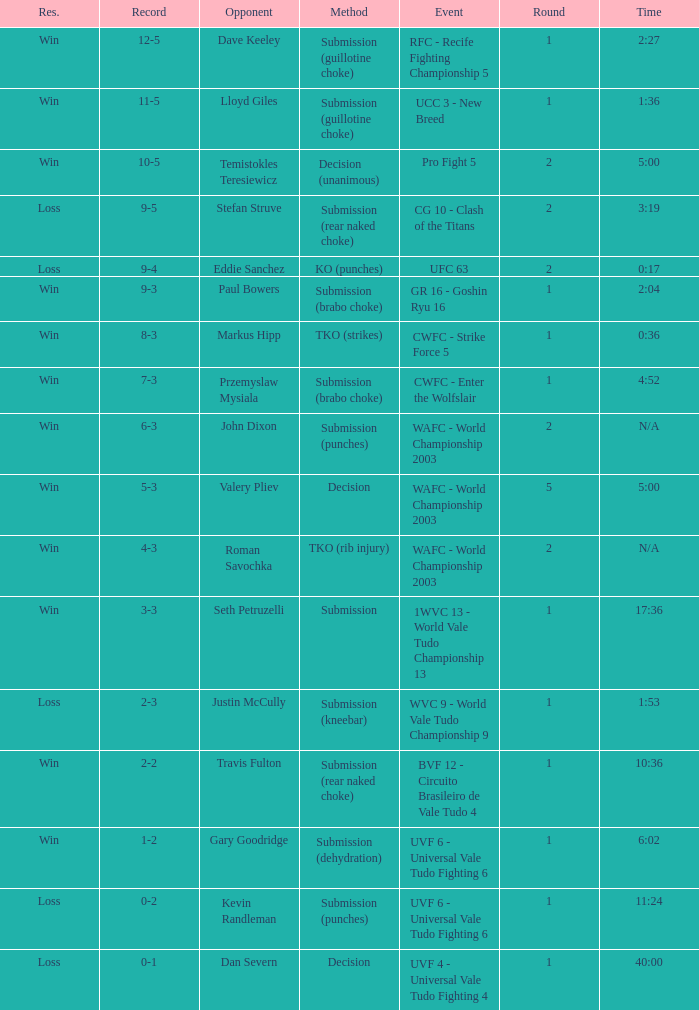Would you mind parsing the complete table? {'header': ['Res.', 'Record', 'Opponent', 'Method', 'Event', 'Round', 'Time'], 'rows': [['Win', '12-5', 'Dave Keeley', 'Submission (guillotine choke)', 'RFC - Recife Fighting Championship 5', '1', '2:27'], ['Win', '11-5', 'Lloyd Giles', 'Submission (guillotine choke)', 'UCC 3 - New Breed', '1', '1:36'], ['Win', '10-5', 'Temistokles Teresiewicz', 'Decision (unanimous)', 'Pro Fight 5', '2', '5:00'], ['Loss', '9-5', 'Stefan Struve', 'Submission (rear naked choke)', 'CG 10 - Clash of the Titans', '2', '3:19'], ['Loss', '9-4', 'Eddie Sanchez', 'KO (punches)', 'UFC 63', '2', '0:17'], ['Win', '9-3', 'Paul Bowers', 'Submission (brabo choke)', 'GR 16 - Goshin Ryu 16', '1', '2:04'], ['Win', '8-3', 'Markus Hipp', 'TKO (strikes)', 'CWFC - Strike Force 5', '1', '0:36'], ['Win', '7-3', 'Przemyslaw Mysiala', 'Submission (brabo choke)', 'CWFC - Enter the Wolfslair', '1', '4:52'], ['Win', '6-3', 'John Dixon', 'Submission (punches)', 'WAFC - World Championship 2003', '2', 'N/A'], ['Win', '5-3', 'Valery Pliev', 'Decision', 'WAFC - World Championship 2003', '5', '5:00'], ['Win', '4-3', 'Roman Savochka', 'TKO (rib injury)', 'WAFC - World Championship 2003', '2', 'N/A'], ['Win', '3-3', 'Seth Petruzelli', 'Submission', '1WVC 13 - World Vale Tudo Championship 13', '1', '17:36'], ['Loss', '2-3', 'Justin McCully', 'Submission (kneebar)', 'WVC 9 - World Vale Tudo Championship 9', '1', '1:53'], ['Win', '2-2', 'Travis Fulton', 'Submission (rear naked choke)', 'BVF 12 - Circuito Brasileiro de Vale Tudo 4', '1', '10:36'], ['Win', '1-2', 'Gary Goodridge', 'Submission (dehydration)', 'UVF 6 - Universal Vale Tudo Fighting 6', '1', '6:02'], ['Loss', '0-2', 'Kevin Randleman', 'Submission (punches)', 'UVF 6 - Universal Vale Tudo Fighting 6', '1', '11:24'], ['Loss', '0-1', 'Dan Severn', 'Decision', 'UVF 4 - Universal Vale Tudo Fighting 4', '1', '40:00']]} What round has the highest Res loss, and a time of 40:00? 1.0. 